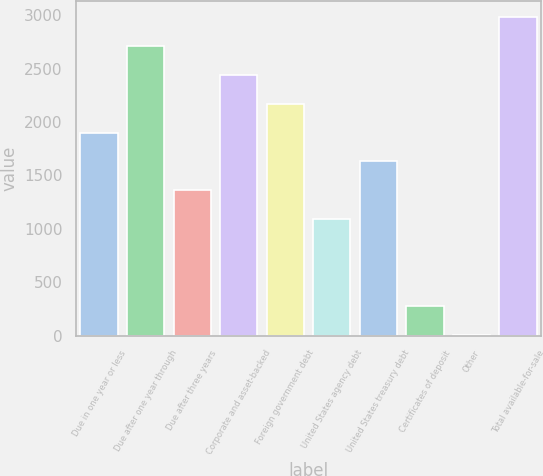Convert chart to OTSL. <chart><loc_0><loc_0><loc_500><loc_500><bar_chart><fcel>Due in one year or less<fcel>Due after one year through<fcel>Due after three years<fcel>Corporate and asset-backed<fcel>Foreign government debt<fcel>United States agency debt<fcel>United States treasury debt<fcel>Certificates of deposit<fcel>Other<fcel>Total available-for-sale<nl><fcel>1900.6<fcel>2713<fcel>1359<fcel>2442.2<fcel>2171.4<fcel>1088.2<fcel>1629.8<fcel>275.8<fcel>5<fcel>2983.8<nl></chart> 